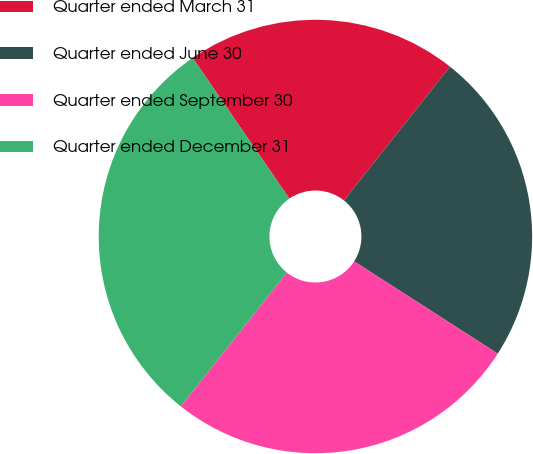Convert chart. <chart><loc_0><loc_0><loc_500><loc_500><pie_chart><fcel>Quarter ended March 31<fcel>Quarter ended June 30<fcel>Quarter ended September 30<fcel>Quarter ended December 31<nl><fcel>20.25%<fcel>23.42%<fcel>26.58%<fcel>29.75%<nl></chart> 